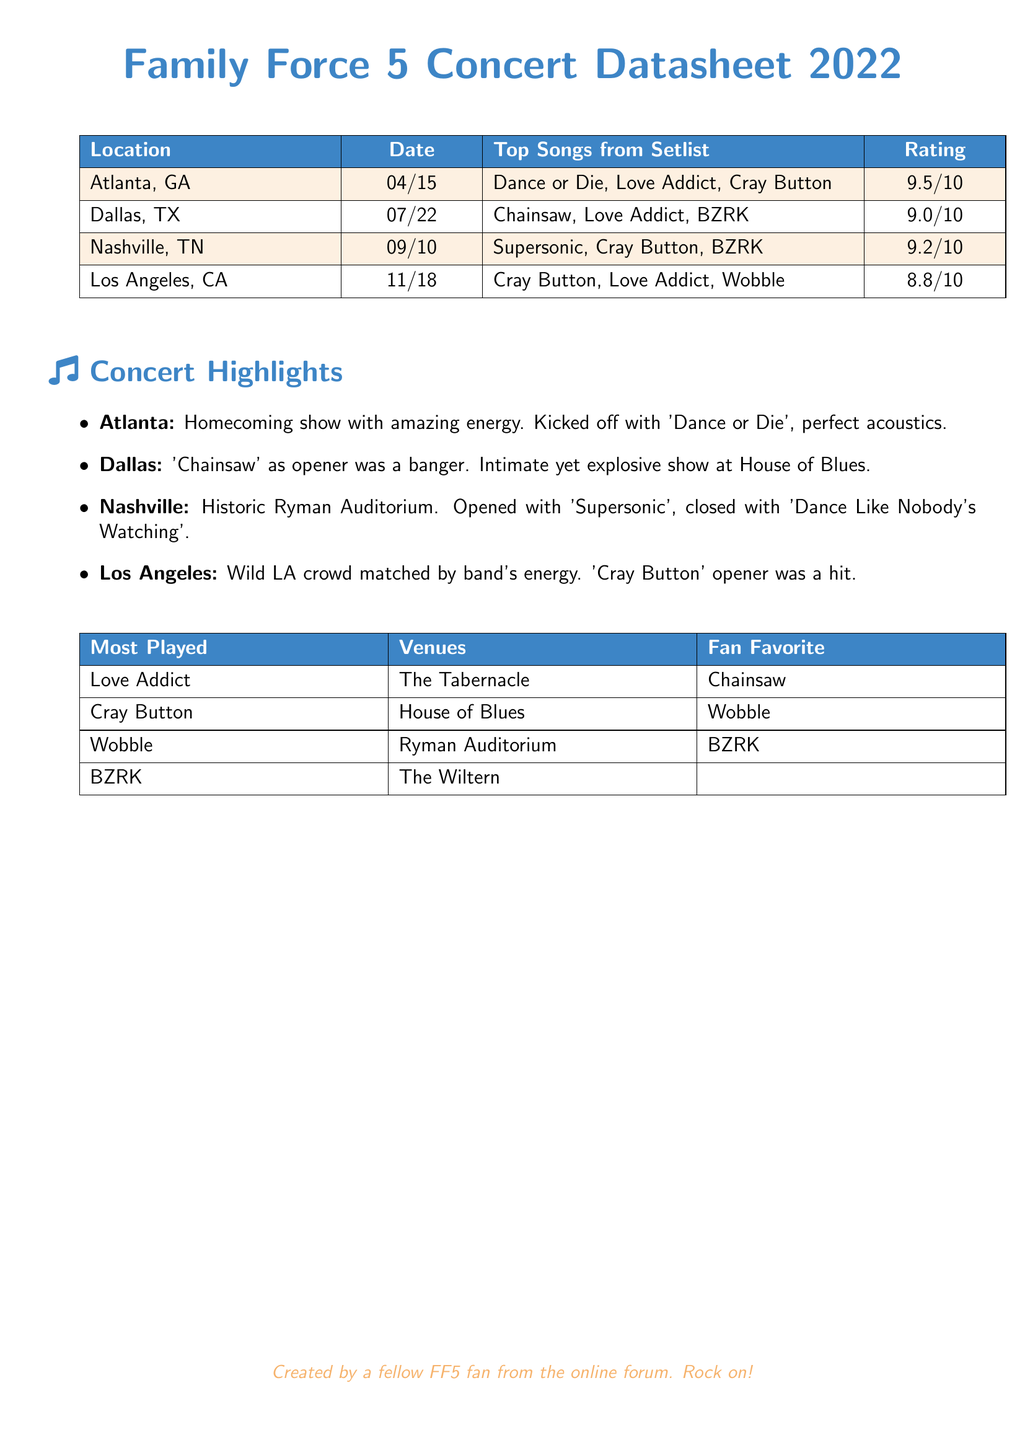What was the date of the Atlanta concert? The date for the Atlanta concert is listed in the document as April 15.
Answer: 04/15 Which song was rated the highest? The rating column shows that the highest-rated song was performed at the Atlanta concert with a score of 9.5.
Answer: 9.5/10 What location hosted the concert on November 18? The location for the November 18 concert can be found in the location column, which lists Los Angeles, CA.
Answer: Los Angeles, CA Which song had the highest number of plays? The table for Most Played indicates that "Love Addict" was the most played song.
Answer: Love Addict How many concerts were listed in the datasheet? The document presents information on four concerts, which can be counted in the setlist section.
Answer: 4 What is the rating for the concert in Dallas? The Dallas concert's rating is found in the document under the rating column, which shows 9.0.
Answer: 9.0/10 Which venue was the fan favorite for the song "Chainsaw"? The Most Played table specifies the venue as House of Blues for the fan favorite "Chainsaw".
Answer: House of Blues What song was the opener for the concert in Nashville? The concert highlights specify 'Supersonic' as the opener for the Nashville show.
Answer: Supersonic Which song closed the concert in Nashville? Based on the concert highlights, the closing song in Nashville was 'Dance Like Nobody's Watching'.
Answer: Dance Like Nobody's Watching 